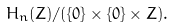<formula> <loc_0><loc_0><loc_500><loc_500>H _ { n } ( { Z } ) / ( \{ 0 \} \times \{ 0 \} \times { Z } ) .</formula> 